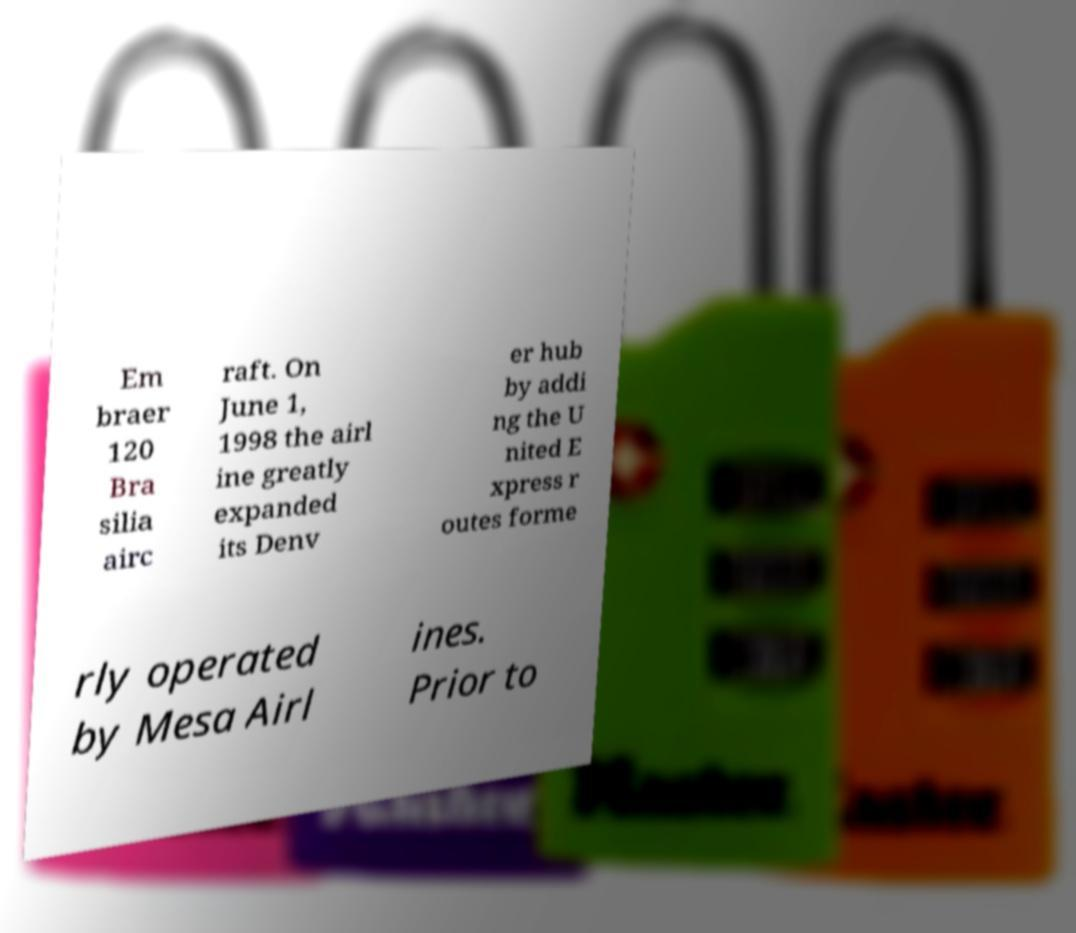There's text embedded in this image that I need extracted. Can you transcribe it verbatim? Em braer 120 Bra silia airc raft. On June 1, 1998 the airl ine greatly expanded its Denv er hub by addi ng the U nited E xpress r outes forme rly operated by Mesa Airl ines. Prior to 